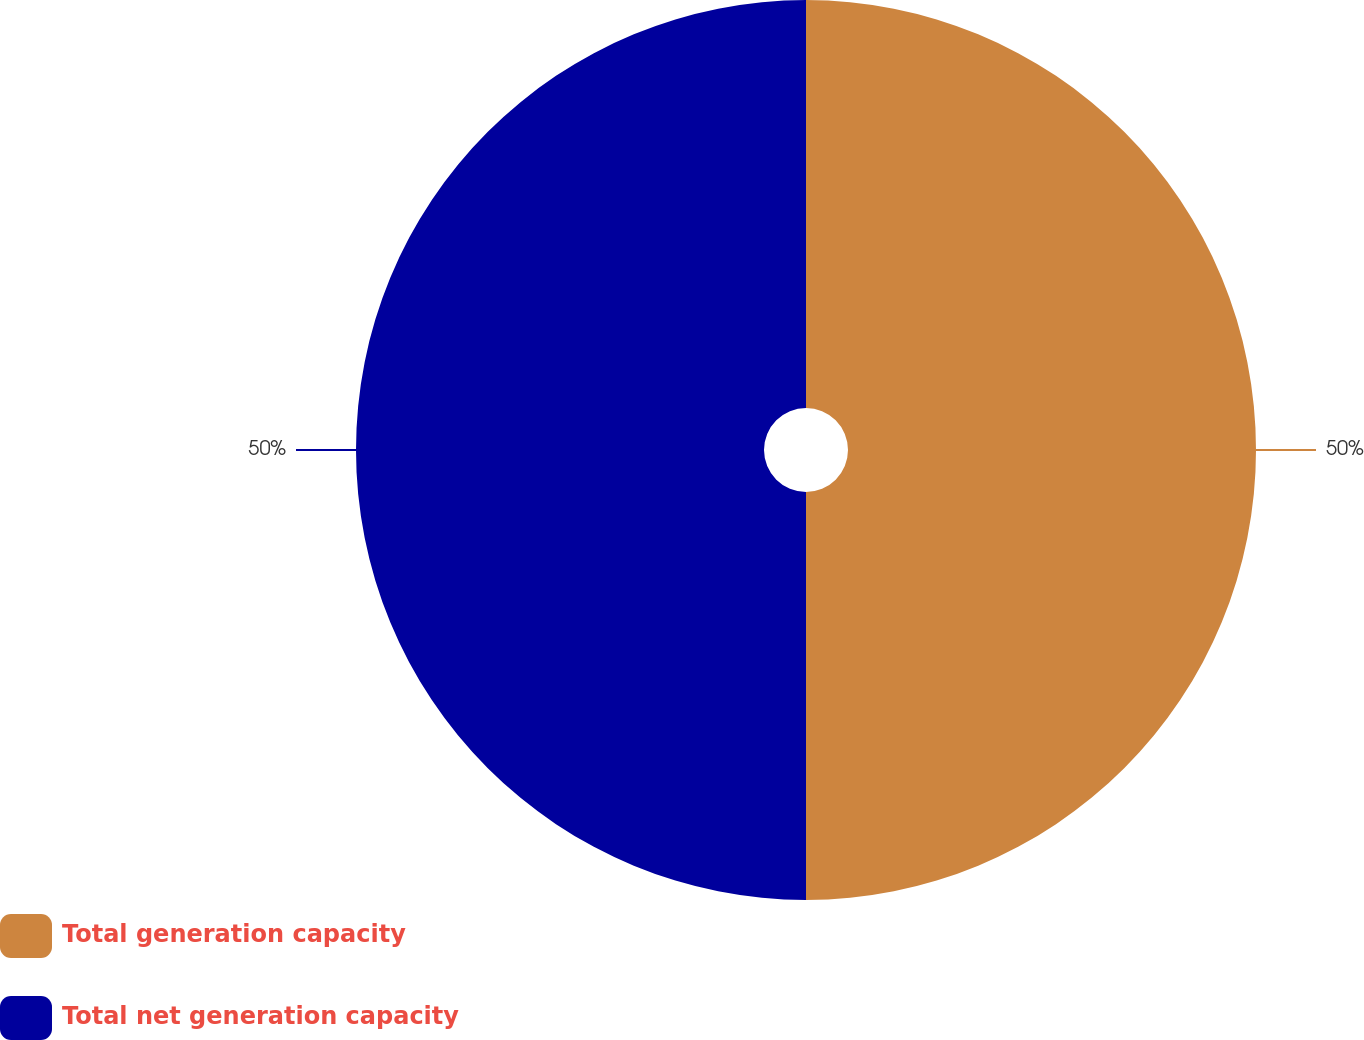Convert chart to OTSL. <chart><loc_0><loc_0><loc_500><loc_500><pie_chart><fcel>Total generation capacity<fcel>Total net generation capacity<nl><fcel>50.0%<fcel>50.0%<nl></chart> 